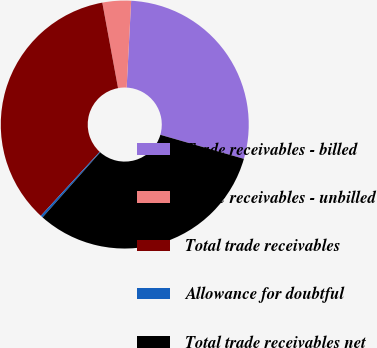Convert chart to OTSL. <chart><loc_0><loc_0><loc_500><loc_500><pie_chart><fcel>Trade receivables - billed<fcel>Trade receivables - unbilled<fcel>Total trade receivables<fcel>Allowance for doubtful<fcel>Total trade receivables net<nl><fcel>28.64%<fcel>3.72%<fcel>35.27%<fcel>0.3%<fcel>32.07%<nl></chart> 